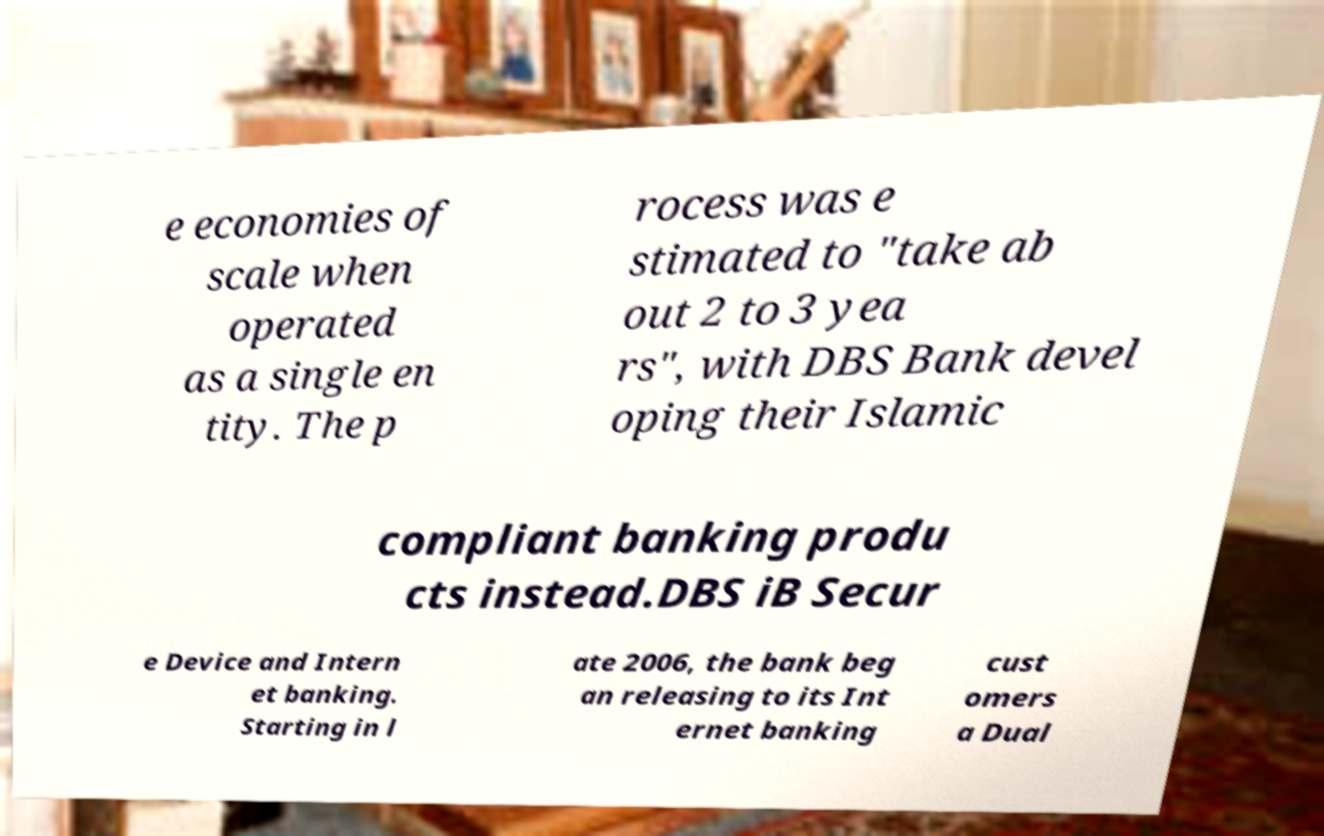What messages or text are displayed in this image? I need them in a readable, typed format. e economies of scale when operated as a single en tity. The p rocess was e stimated to "take ab out 2 to 3 yea rs", with DBS Bank devel oping their Islamic compliant banking produ cts instead.DBS iB Secur e Device and Intern et banking. Starting in l ate 2006, the bank beg an releasing to its Int ernet banking cust omers a Dual 